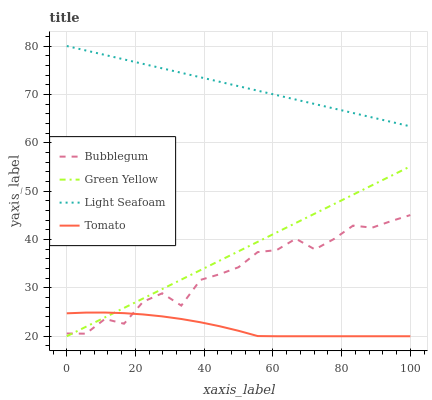Does Green Yellow have the minimum area under the curve?
Answer yes or no. No. Does Green Yellow have the maximum area under the curve?
Answer yes or no. No. Is Tomato the smoothest?
Answer yes or no. No. Is Tomato the roughest?
Answer yes or no. No. Does Bubblegum have the lowest value?
Answer yes or no. No. Does Green Yellow have the highest value?
Answer yes or no. No. Is Bubblegum less than Light Seafoam?
Answer yes or no. Yes. Is Light Seafoam greater than Bubblegum?
Answer yes or no. Yes. Does Bubblegum intersect Light Seafoam?
Answer yes or no. No. 